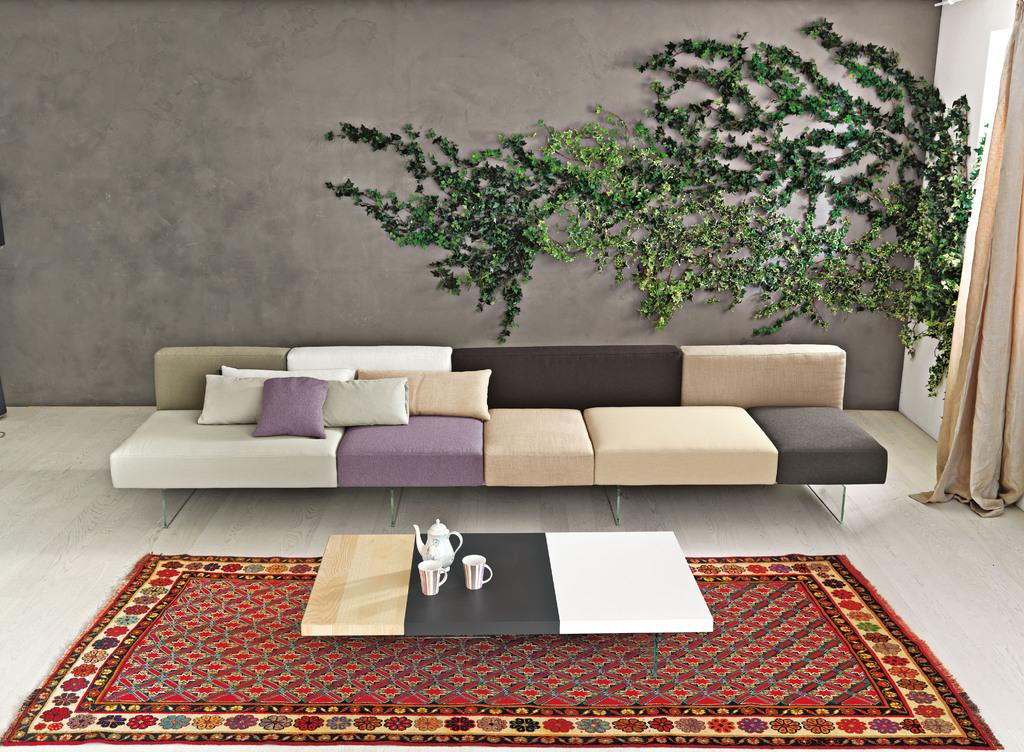Where is the image taken? The image is taken in a living room. What furniture is present in the living room? There is a couch in the living room. How many pillows are on the couch? There are 4 pillows on the couch. What other items can be seen in the living room? There is a table in the living room, with glasses and a tea pot on it. What type of flooring is present in the living room? There is a carpet in the living room. Is there any greenery in the living room? Yes, there is a plant in the living room, either kept on the floor or attached to a wall. Is there any window treatment present in the living room? Yes, there is a curtain associated with a window. How many windows are in the living room? There is one window in the living room. What type of tongue can be seen sticking out of the plant in the image? There is no tongue present in the image, as it features a living room with various items and a plant. 